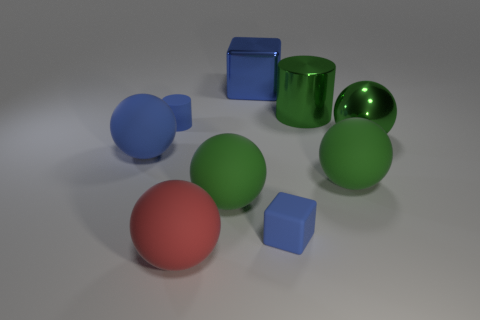Is the matte cylinder the same color as the large cube?
Your response must be concise. Yes. There is a big green shiny cylinder; are there any green metallic cylinders on the left side of it?
Offer a very short reply. No. Are there the same number of green rubber balls that are to the left of the metallic cylinder and green metallic cylinders that are left of the big cube?
Your answer should be very brief. No. There is a rubber ball that is left of the red matte sphere; does it have the same size as the blue matte object that is in front of the big blue matte sphere?
Make the answer very short. No. There is a small blue rubber object that is right of the green rubber ball in front of the green matte sphere on the right side of the large blue metal thing; what shape is it?
Your answer should be very brief. Cube. The green metal thing that is the same shape as the large blue rubber thing is what size?
Keep it short and to the point. Large. The matte thing that is on the left side of the big cylinder and right of the big shiny block is what color?
Your answer should be very brief. Blue. Is the material of the green cylinder the same as the large ball behind the big blue matte object?
Your answer should be very brief. Yes. Are there fewer metallic cylinders that are to the right of the blue metallic block than green things?
Provide a short and direct response. Yes. How many other things are the same shape as the large red object?
Your answer should be very brief. 4. 